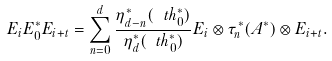Convert formula to latex. <formula><loc_0><loc_0><loc_500><loc_500>E _ { i } E ^ { * } _ { 0 } E _ { i + t } = \sum _ { n = 0 } ^ { d } \frac { \eta ^ { * } _ { d - n } ( \ t h ^ { * } _ { 0 } ) } { \eta ^ { * } _ { d } ( \ t h ^ { * } _ { 0 } ) } E _ { i } \otimes \tau ^ { * } _ { n } ( A ^ { * } ) \otimes E _ { i + t } .</formula> 